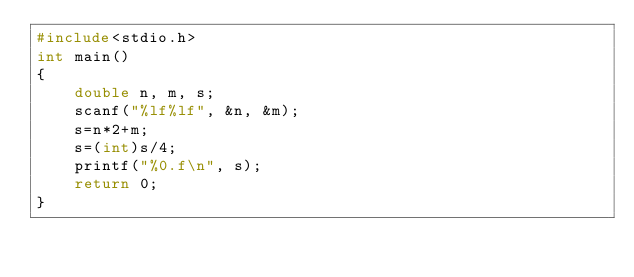<code> <loc_0><loc_0><loc_500><loc_500><_C_>#include<stdio.h>
int main()
{
    double n, m, s;
    scanf("%lf%lf", &n, &m);
    s=n*2+m;
    s=(int)s/4;
    printf("%0.f\n", s);
    return 0;
}
</code> 